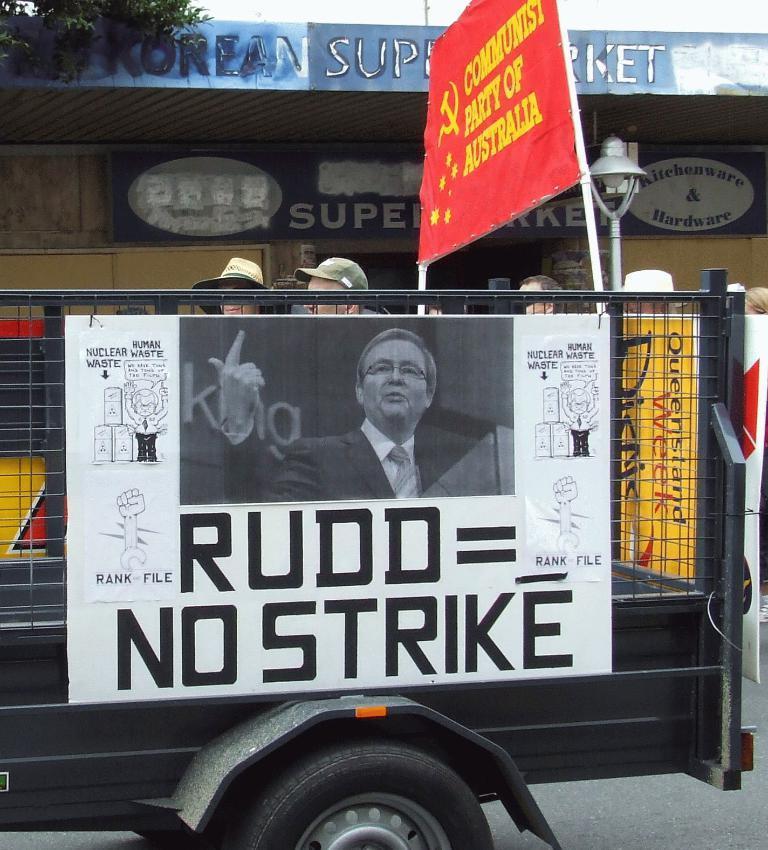Can you describe this image briefly? This picture is clicked outside. In the foreground we can see a board attached to the vehicle and we can see the picture of a person and the text is printed on the board. In the background we can see the group of people, lamp attached to the pole and the text on the boards and a building and we can see a tree. 